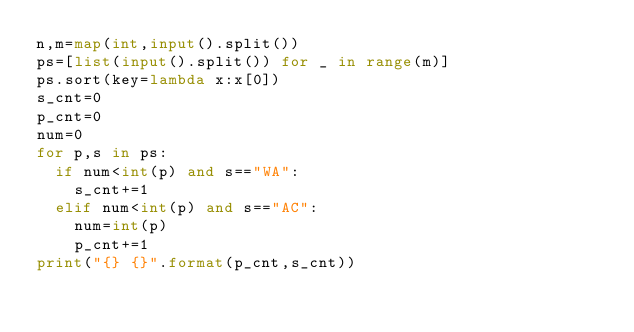<code> <loc_0><loc_0><loc_500><loc_500><_Python_>n,m=map(int,input().split())
ps=[list(input().split()) for _ in range(m)]
ps.sort(key=lambda x:x[0])
s_cnt=0
p_cnt=0
num=0
for p,s in ps:
  if num<int(p) and s=="WA":
    s_cnt+=1
  elif num<int(p) and s=="AC":
    num=int(p)
    p_cnt+=1
print("{} {}".format(p_cnt,s_cnt))</code> 